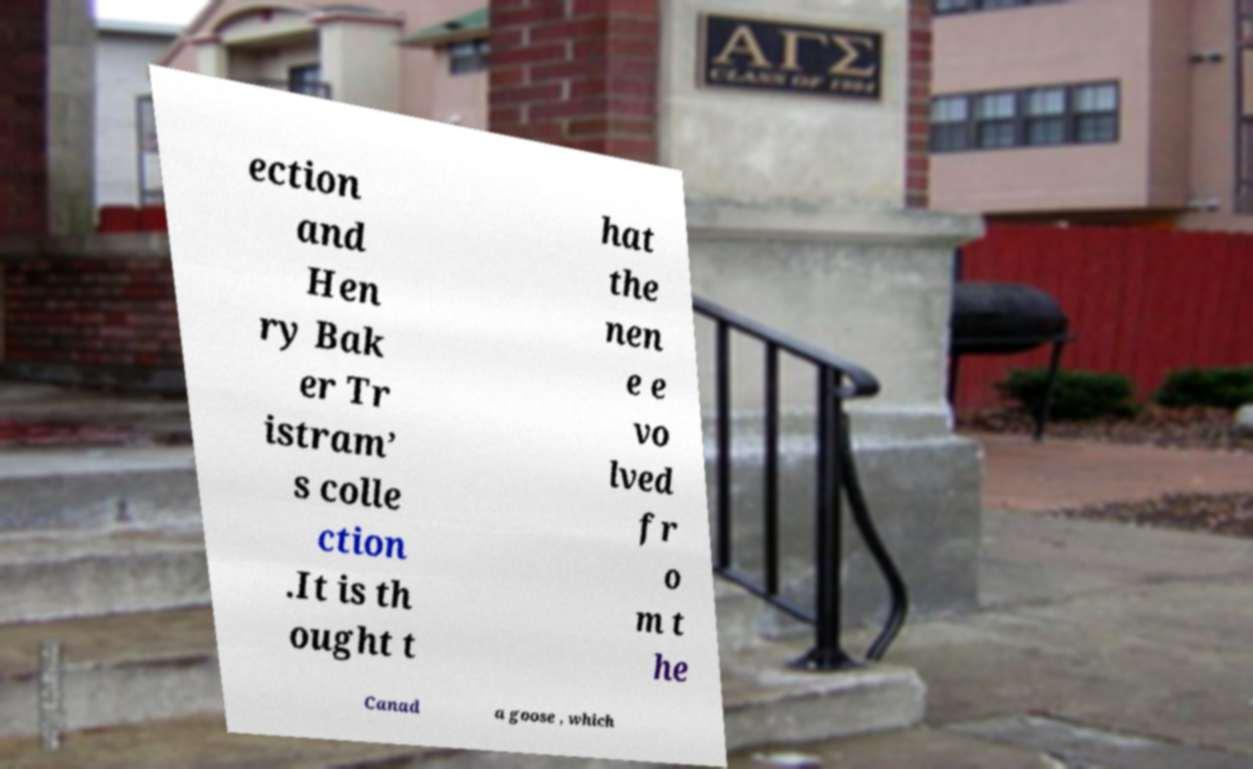There's text embedded in this image that I need extracted. Can you transcribe it verbatim? ection and Hen ry Bak er Tr istram’ s colle ction .It is th ought t hat the nen e e vo lved fr o m t he Canad a goose , which 